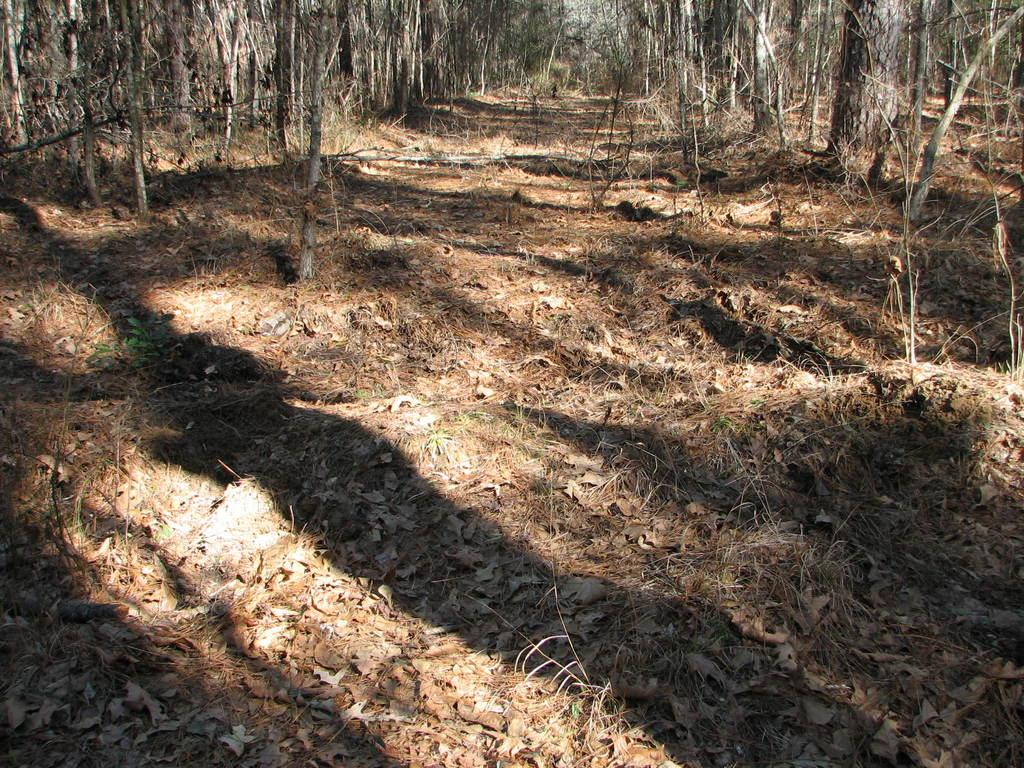What type of environment is shown in the image? The image depicts a forest area. What can be found on the ground in the forest? Dried leaves are present on the ground. What are the main features of the forest? Trees are visible in the image, and tree trunks are also present. What color is the roof of the tree in the image? There is no roof present in the image, as trees do not have roofs. 